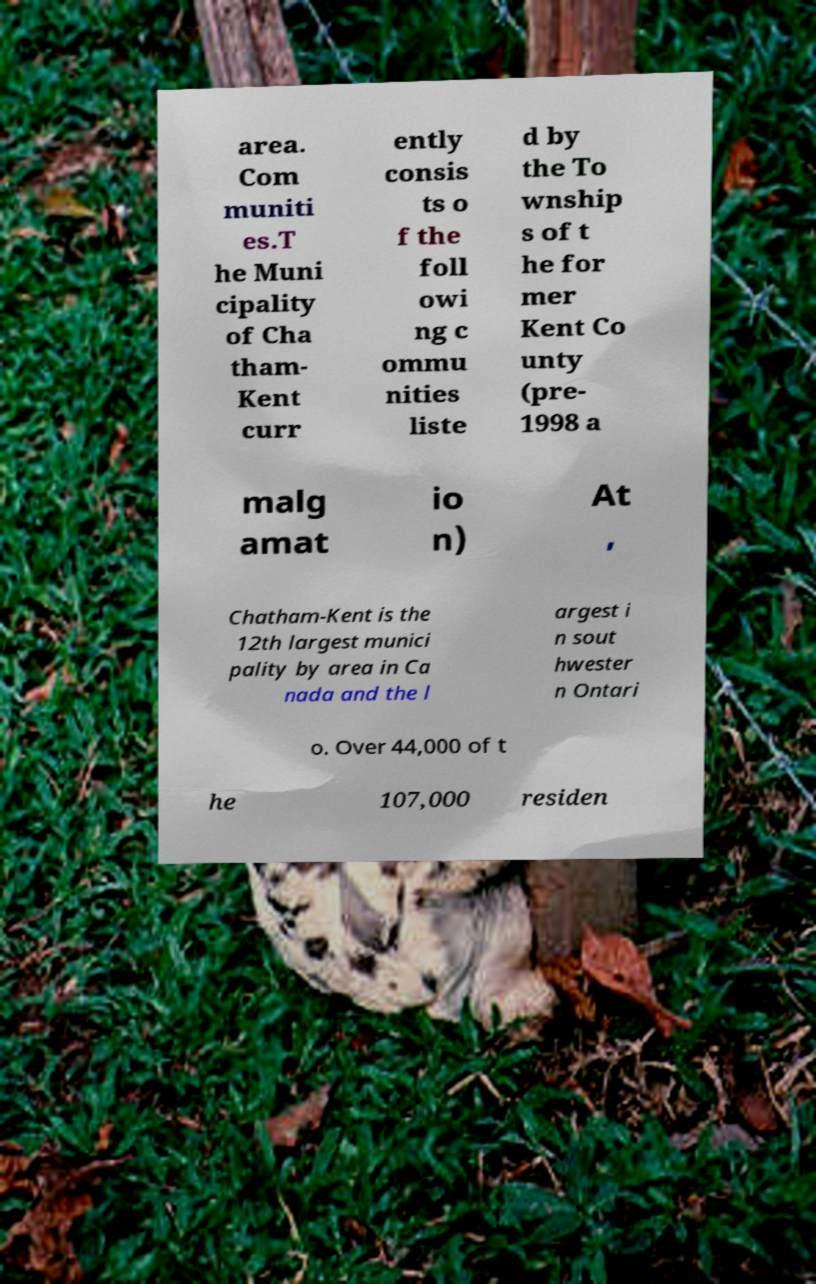What messages or text are displayed in this image? I need them in a readable, typed format. area. Com muniti es.T he Muni cipality of Cha tham- Kent curr ently consis ts o f the foll owi ng c ommu nities liste d by the To wnship s of t he for mer Kent Co unty (pre- 1998 a malg amat io n) At , Chatham-Kent is the 12th largest munici pality by area in Ca nada and the l argest i n sout hwester n Ontari o. Over 44,000 of t he 107,000 residen 